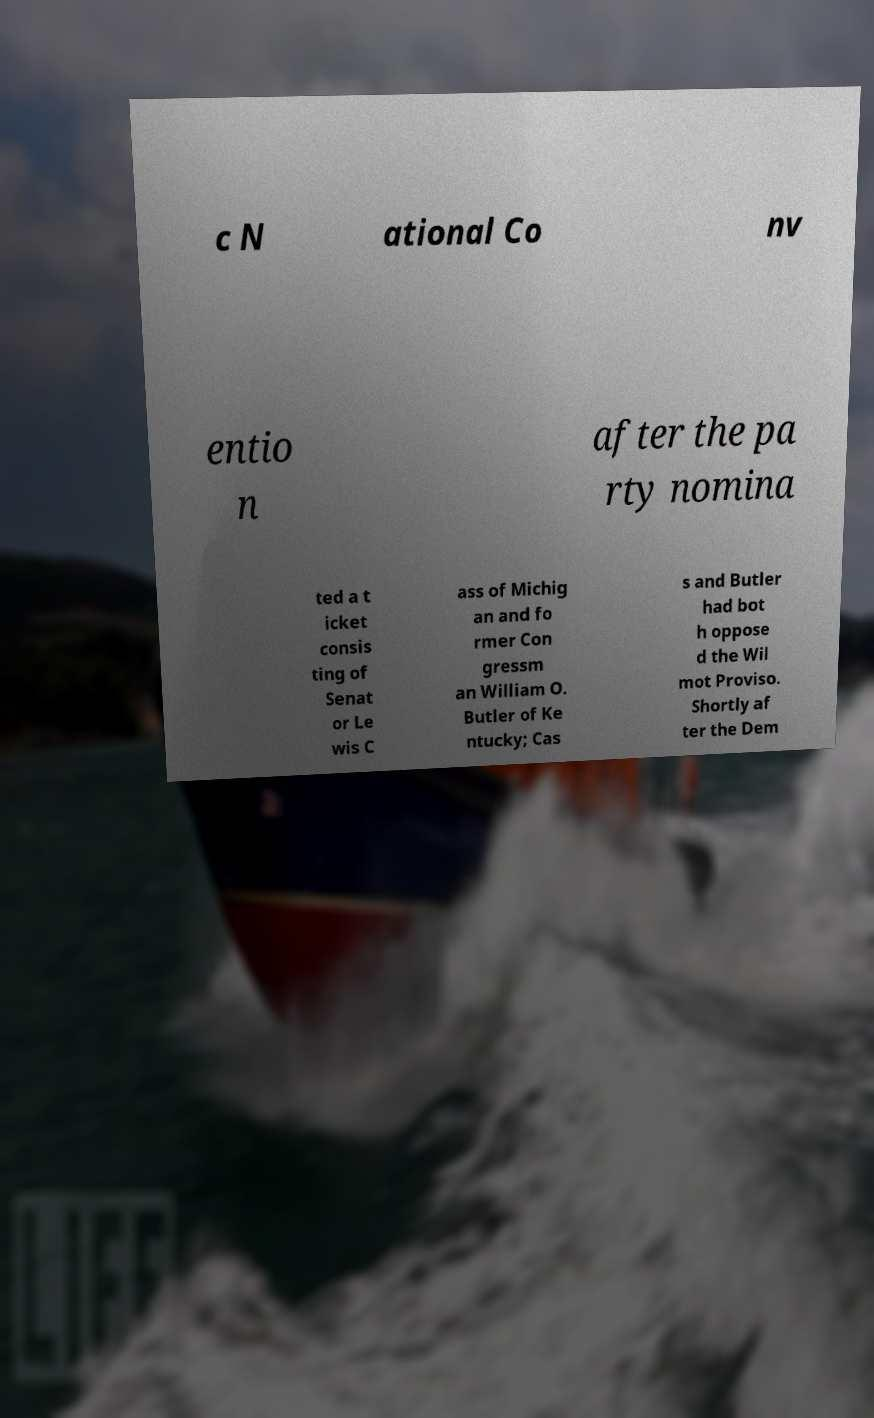I need the written content from this picture converted into text. Can you do that? c N ational Co nv entio n after the pa rty nomina ted a t icket consis ting of Senat or Le wis C ass of Michig an and fo rmer Con gressm an William O. Butler of Ke ntucky; Cas s and Butler had bot h oppose d the Wil mot Proviso. Shortly af ter the Dem 